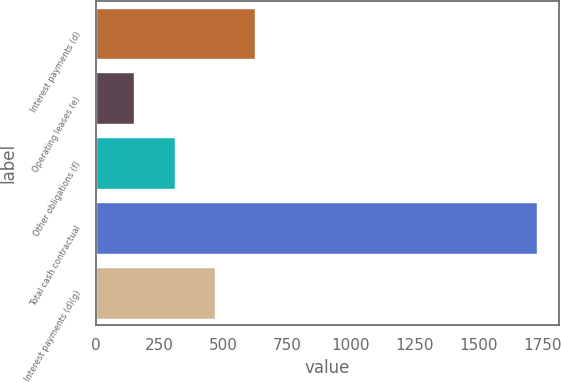Convert chart. <chart><loc_0><loc_0><loc_500><loc_500><bar_chart><fcel>Interest payments (d)<fcel>Operating leases (e)<fcel>Other obligations (f)<fcel>Total cash contractual<fcel>Interest payments (d)(g)<nl><fcel>625.1<fcel>152<fcel>309.7<fcel>1729<fcel>467.4<nl></chart> 